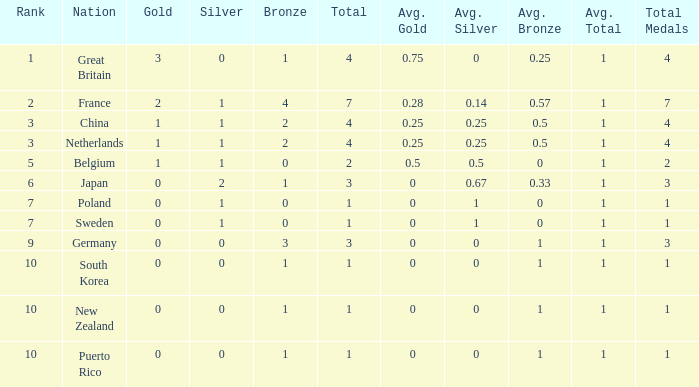What is the total where the gold is larger than 2? 1.0. 